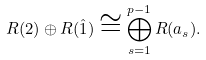<formula> <loc_0><loc_0><loc_500><loc_500>R ( 2 ) \oplus R ( \hat { 1 } ) \cong \bigoplus _ { s = 1 } ^ { p - 1 } R ( a _ { s } ) .</formula> 